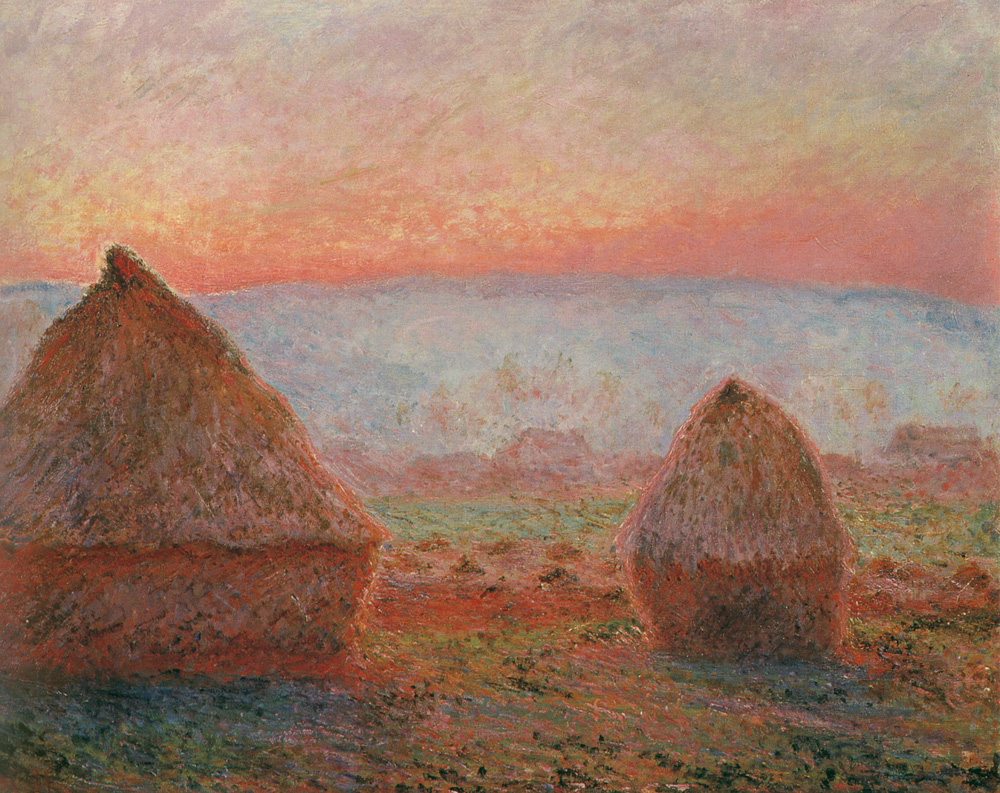What is this photo about? The image is an exquisite example of an impressionist painting, focusing on a serene rural landscape during sunset. It highlights two prominent haystacks that catch the fading sunlight, which softly brushes the scene with pink and orange hues. These colors create a warm, calming atmosphere across the landscape. Painterly, free-form brushstrokes typical of impressionism add vibrancy, suggesting a gentle breeze and the peaceful end of a day. Likely crafted to evoke tranquility and the fleeting beauty of natural light, the painting invites viewers to reflect on simplicity and the rustic beauty of countryside life. 